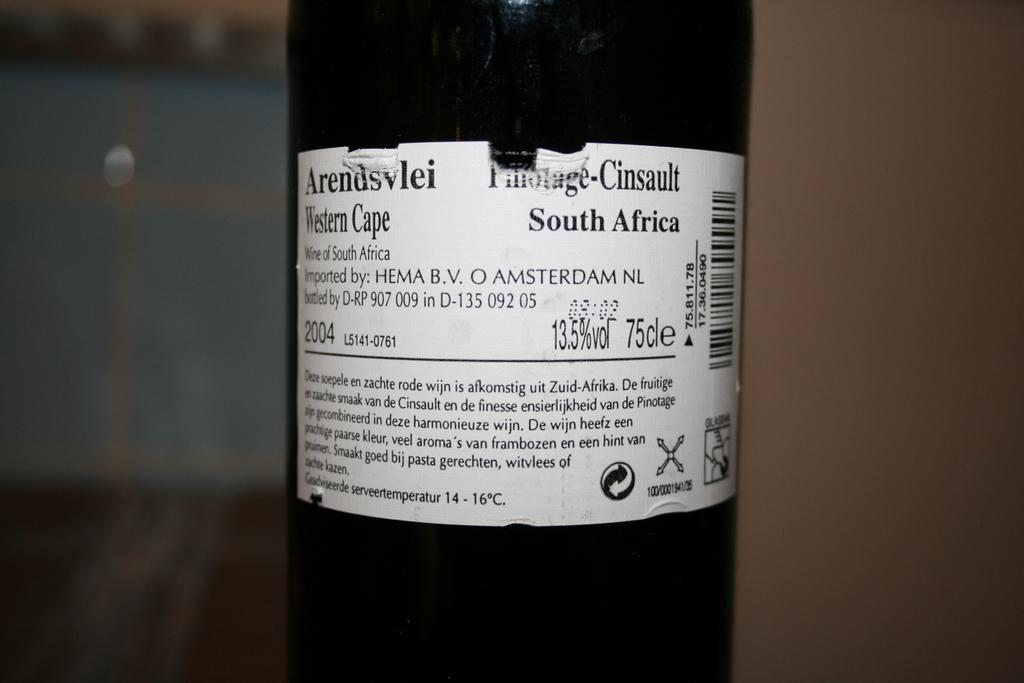Provide a one-sentence caption for the provided image. The wine was bottled on the Western Cape of South Africa. 